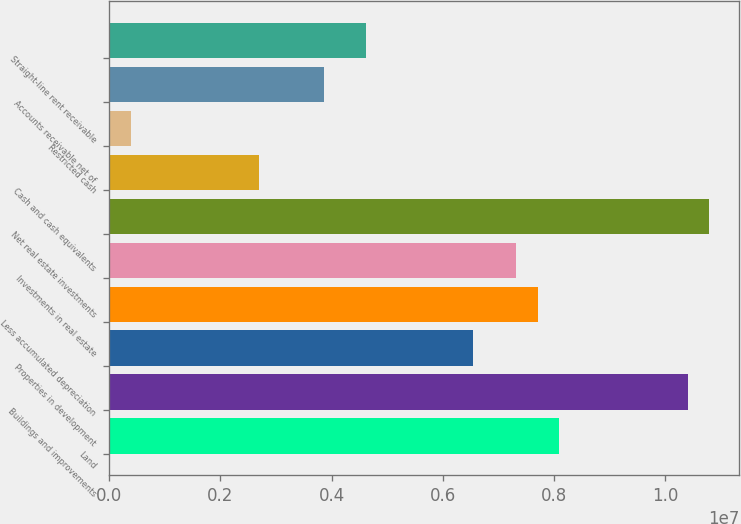<chart> <loc_0><loc_0><loc_500><loc_500><bar_chart><fcel>Land<fcel>Buildings and improvements<fcel>Properties in development<fcel>Less accumulated depreciation<fcel>Investments in real estate<fcel>Net real estate investments<fcel>Cash and cash equivalents<fcel>Restricted cash<fcel>Accounts receivable net of<fcel>Straight-line rent receivable<nl><fcel>8.09099e+06<fcel>1.04024e+07<fcel>6.55007e+06<fcel>7.70576e+06<fcel>7.32053e+06<fcel>1.07876e+07<fcel>2.69777e+06<fcel>386384<fcel>3.85346e+06<fcel>4.62392e+06<nl></chart> 